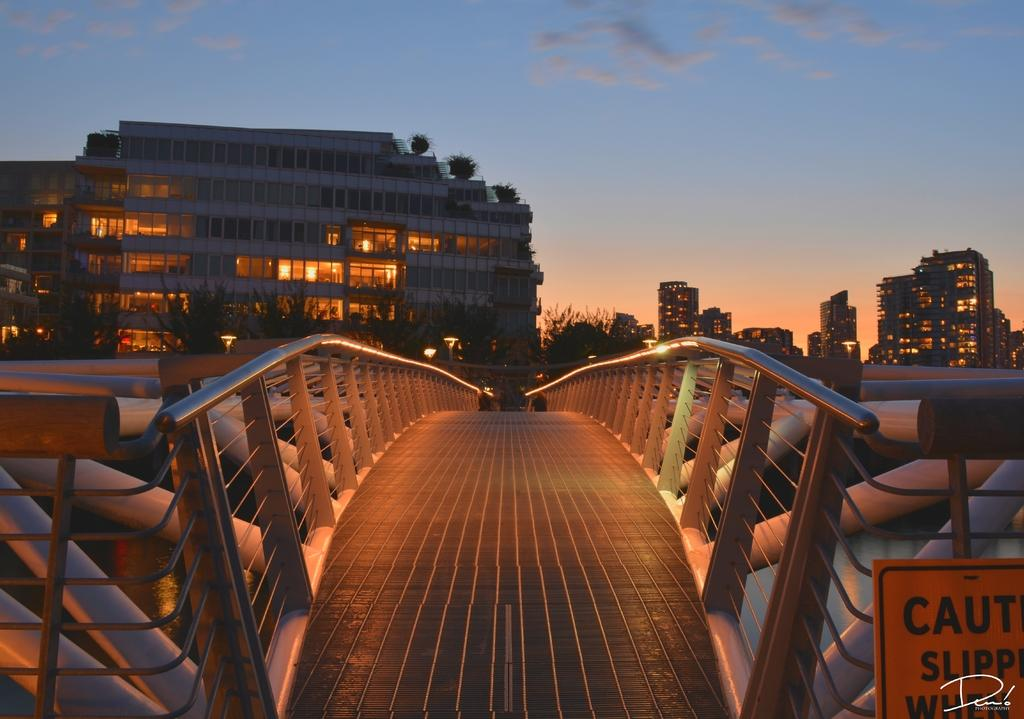<image>
Present a compact description of the photo's key features. a bridge at sunset with half of a sign which appears to read caution 